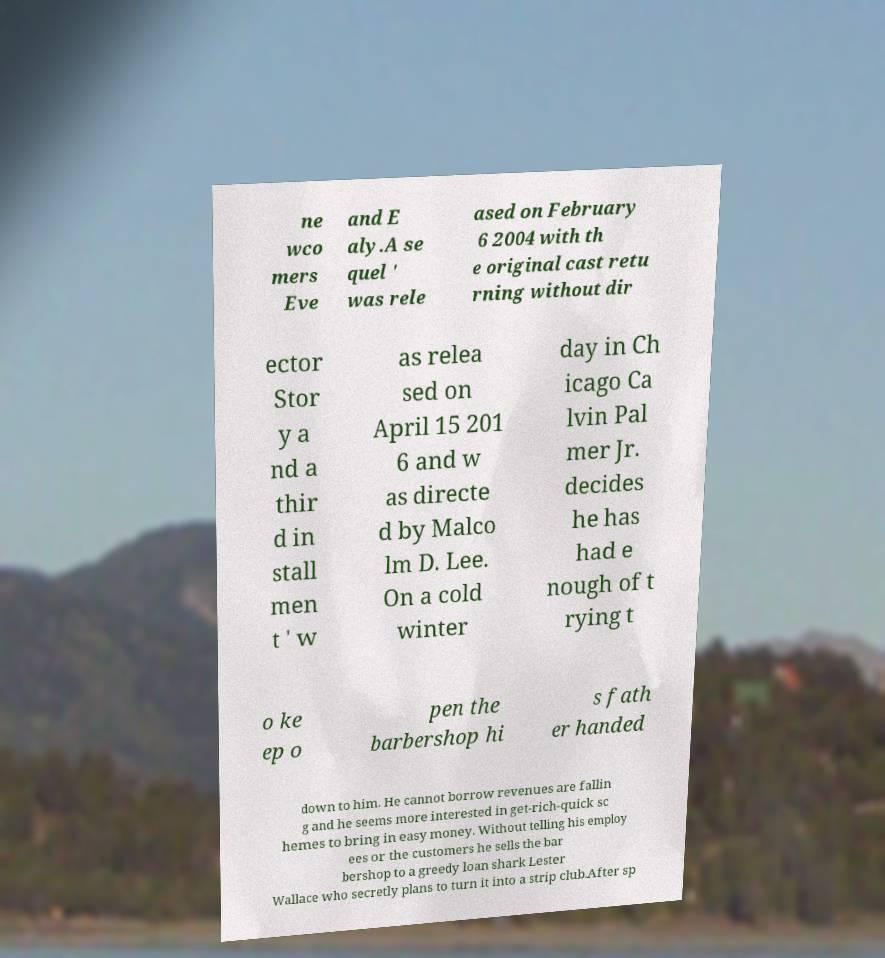Could you extract and type out the text from this image? ne wco mers Eve and E aly.A se quel ' was rele ased on February 6 2004 with th e original cast retu rning without dir ector Stor y a nd a thir d in stall men t ' w as relea sed on April 15 201 6 and w as directe d by Malco lm D. Lee. On a cold winter day in Ch icago Ca lvin Pal mer Jr. decides he has had e nough of t rying t o ke ep o pen the barbershop hi s fath er handed down to him. He cannot borrow revenues are fallin g and he seems more interested in get-rich-quick sc hemes to bring in easy money. Without telling his employ ees or the customers he sells the bar bershop to a greedy loan shark Lester Wallace who secretly plans to turn it into a strip club.After sp 